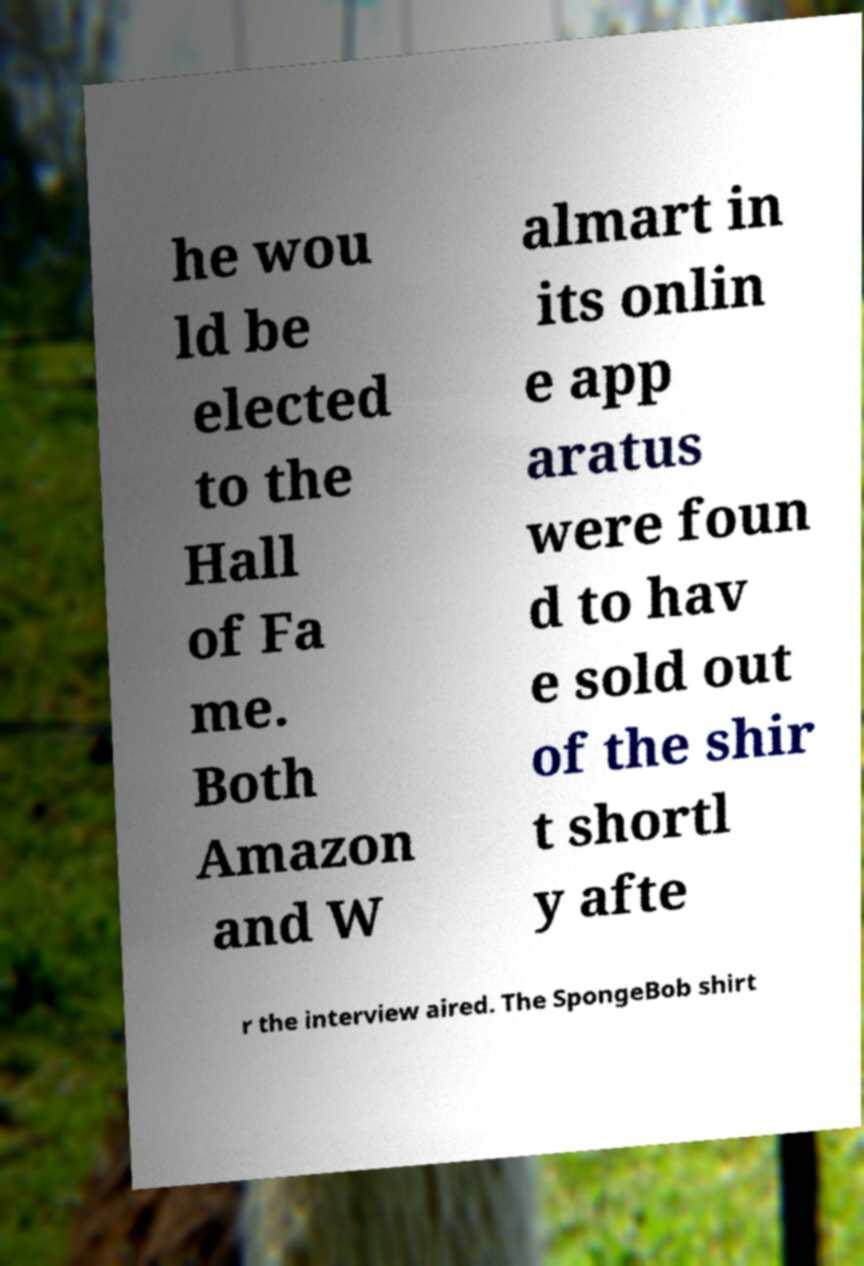Can you read and provide the text displayed in the image?This photo seems to have some interesting text. Can you extract and type it out for me? he wou ld be elected to the Hall of Fa me. Both Amazon and W almart in its onlin e app aratus were foun d to hav e sold out of the shir t shortl y afte r the interview aired. The SpongeBob shirt 